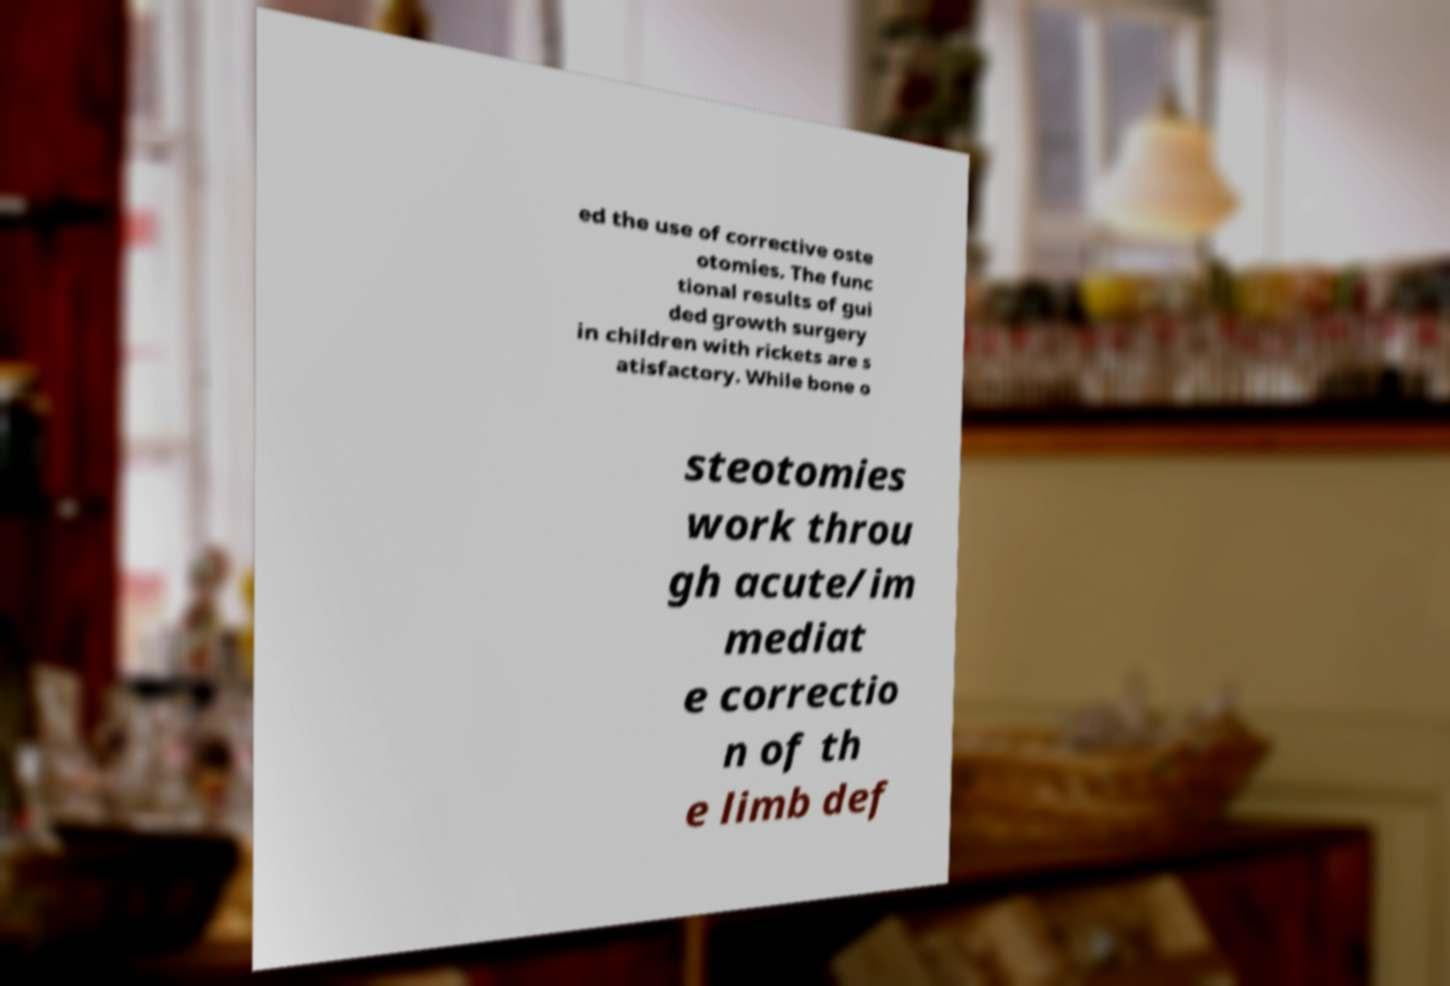Please identify and transcribe the text found in this image. ed the use of corrective oste otomies. The func tional results of gui ded growth surgery in children with rickets are s atisfactory. While bone o steotomies work throu gh acute/im mediat e correctio n of th e limb def 